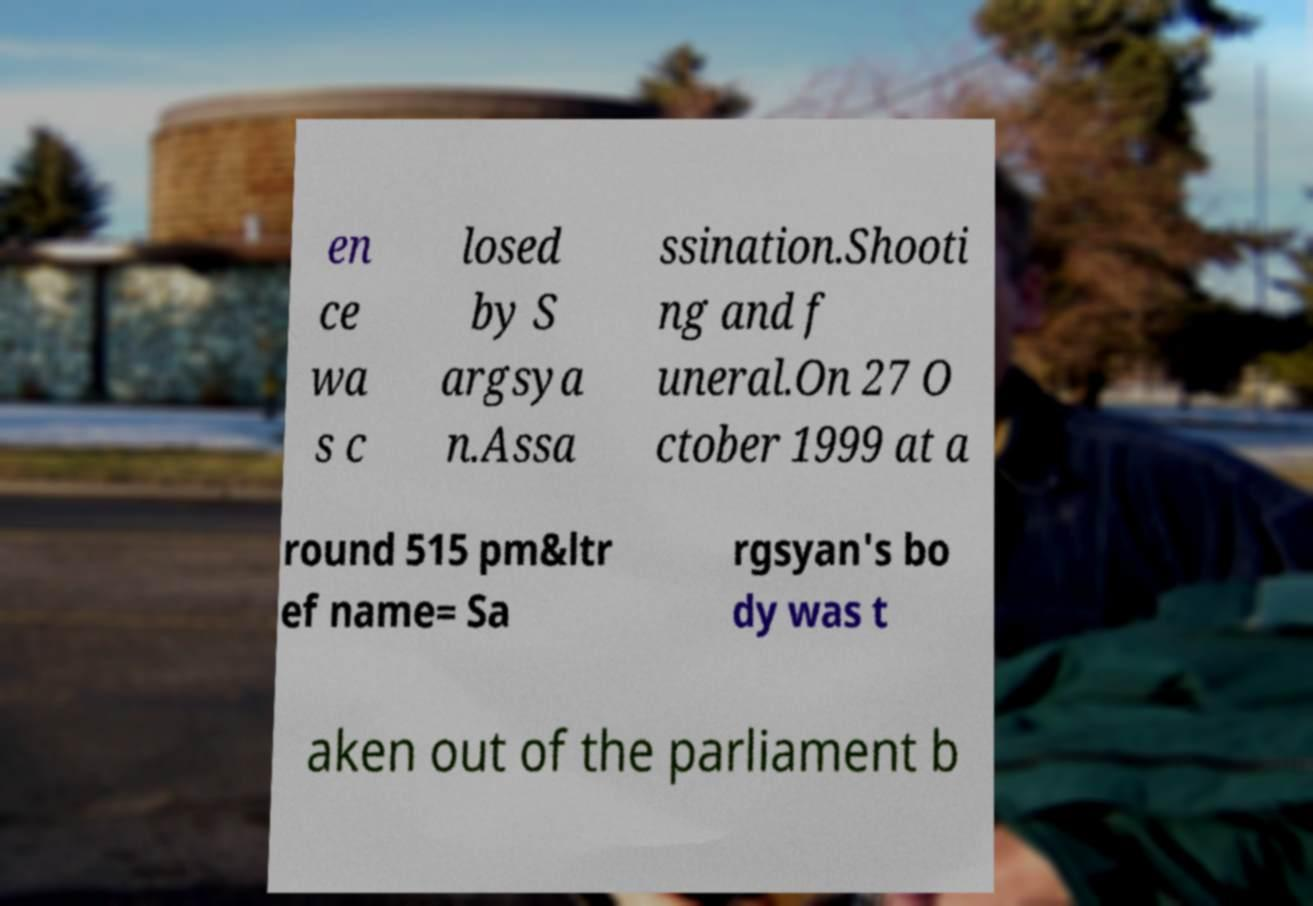Could you assist in decoding the text presented in this image and type it out clearly? en ce wa s c losed by S argsya n.Assa ssination.Shooti ng and f uneral.On 27 O ctober 1999 at a round 515 pm&ltr ef name= Sa rgsyan's bo dy was t aken out of the parliament b 